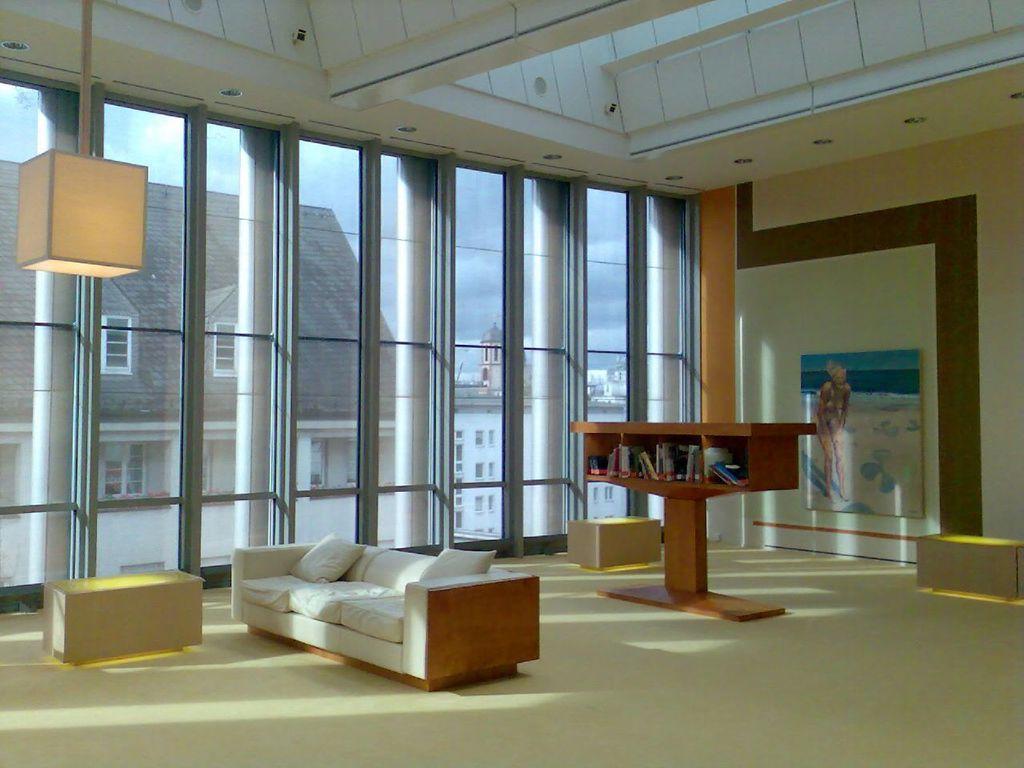Can you describe this image briefly? This is a room. In this room there is a sofa with pillows, benches, cupboards, there are books in the cupboards. On the wall there is a photo frame. Also there is a glass wall. In the background there is a building with windows. 